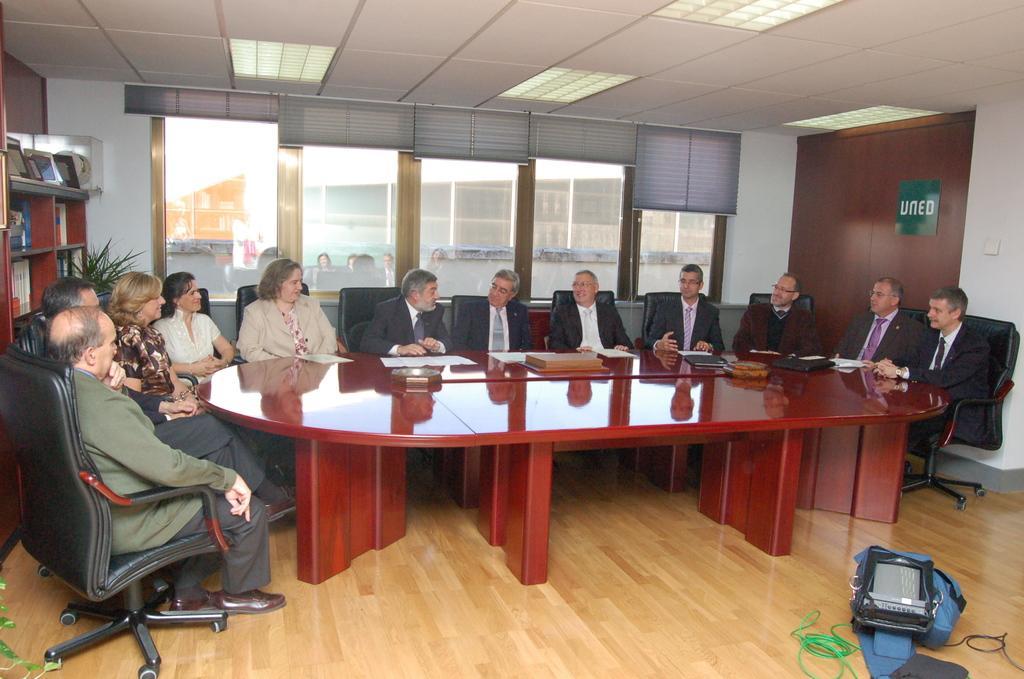Describe this image in one or two sentences. In this picture there are group of people sitting on a chair. There is a paper, box, black file on a red table. There is a device, black and green wire, bag on the floor. There is a plant in the corner. Few books are arranged in a shelf. 